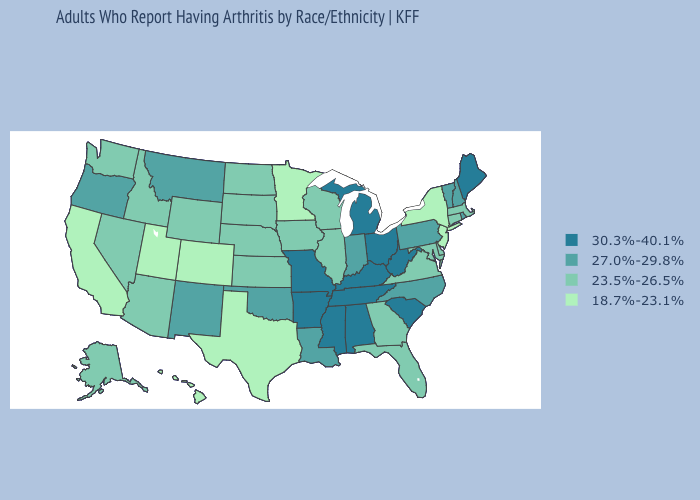How many symbols are there in the legend?
Answer briefly. 4. Does Nevada have a higher value than California?
Quick response, please. Yes. Name the states that have a value in the range 23.5%-26.5%?
Short answer required. Alaska, Arizona, Connecticut, Delaware, Florida, Georgia, Idaho, Illinois, Iowa, Kansas, Maryland, Massachusetts, Nebraska, Nevada, North Dakota, South Dakota, Virginia, Washington, Wisconsin, Wyoming. Name the states that have a value in the range 23.5%-26.5%?
Concise answer only. Alaska, Arizona, Connecticut, Delaware, Florida, Georgia, Idaho, Illinois, Iowa, Kansas, Maryland, Massachusetts, Nebraska, Nevada, North Dakota, South Dakota, Virginia, Washington, Wisconsin, Wyoming. Does the map have missing data?
Write a very short answer. No. What is the value of Oklahoma?
Keep it brief. 27.0%-29.8%. What is the highest value in states that border Washington?
Be succinct. 27.0%-29.8%. How many symbols are there in the legend?
Keep it brief. 4. Name the states that have a value in the range 23.5%-26.5%?
Give a very brief answer. Alaska, Arizona, Connecticut, Delaware, Florida, Georgia, Idaho, Illinois, Iowa, Kansas, Maryland, Massachusetts, Nebraska, Nevada, North Dakota, South Dakota, Virginia, Washington, Wisconsin, Wyoming. Which states have the lowest value in the USA?
Keep it brief. California, Colorado, Hawaii, Minnesota, New Jersey, New York, Texas, Utah. Does the first symbol in the legend represent the smallest category?
Write a very short answer. No. What is the value of South Dakota?
Quick response, please. 23.5%-26.5%. What is the lowest value in states that border Oregon?
Give a very brief answer. 18.7%-23.1%. What is the lowest value in the South?
Concise answer only. 18.7%-23.1%. What is the lowest value in the USA?
Concise answer only. 18.7%-23.1%. 